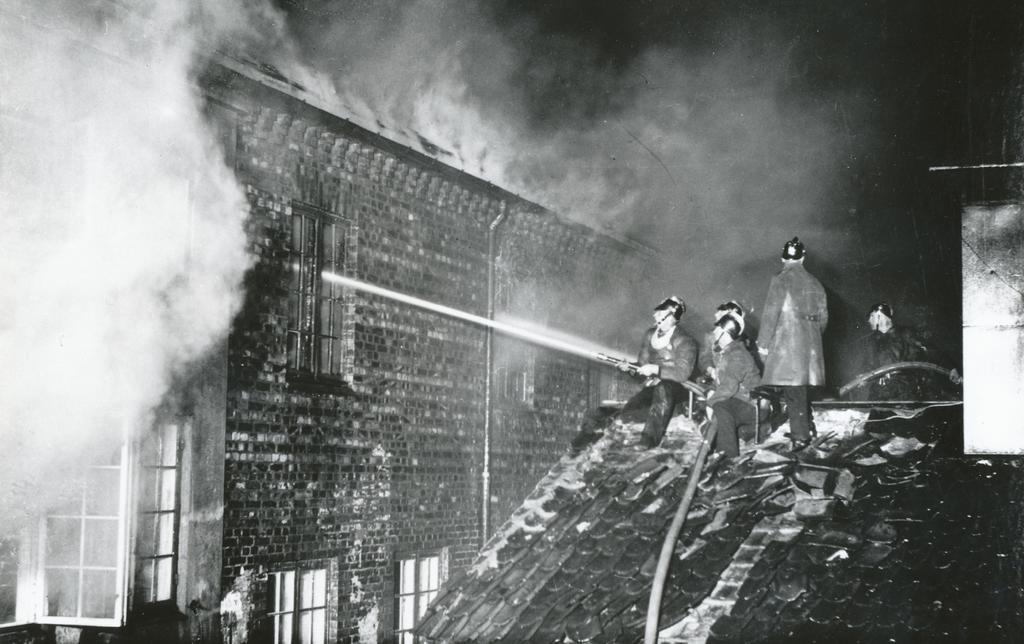Can you describe this image briefly? In this picture we can see five persons on the right side, a person on the left is holding a water pipe, on the left there is a building, we can also see smoke, there is the sky at the top of the picture, we can see windows of this building, it is a black and white image, these people wore helmets. 